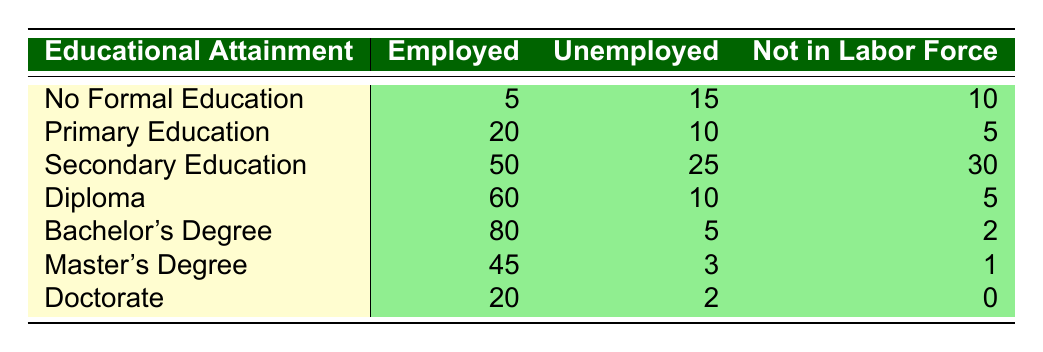What is the total number of unemployed Qatari citizens with a Bachelor's Degree? In the table, we find that the number of unemployed individuals with a Bachelor's Degree is listed as 5. Thus, the total number of unemployed Qatari citizens with this level of education is simply the number stated for that category.
Answer: 5 How many Qatari citizens are employed with only Primary Education? According to the table, under the category of Primary Education, the number of employed Qatari citizens is noted as 20. Therefore, this is a straightforward retrieval of the value from the table.
Answer: 20 What is the total number of Qatari citizens with no formal education? We need to sum the numbers of Employed, Unemployed, and Not in Labor Force for those with No Formal Education. It is calculated as 5 (Employed) + 15 (Unemployed) + 10 (Not in Labor Force) = 30. Hence, the total number of Qatari citizens with no formal education is 30.
Answer: 30 Is it true that more Qatari citizens with a Master's Degree are employed compared to those with a Doctorate? From the table, for Master's Degree we see 45 employed, while for Doctorate there are 20 employed. Since 45 is greater than 20, the statement is true.
Answer: Yes What is the average number of Qatari citizens employed across all educational attainment levels listed in the table? We sum all the Employed values: 5 + 20 + 50 + 60 + 80 + 45 + 20 = 280. There are 7 educational levels, so we calculate the average as 280 / 7 = 40.
Answer: 40 Which educational attainment level has the highest number of unemployed citizens? Looking at the table, we identify the highest value under the Unemployed column. The highest count is 25 under Secondary Education, which is greater than any other level listed.
Answer: Secondary Education How many Qatari citizens with a Diploma are either unemployed or not in the labor force? We add the Unemployed (10) and Not in Labor Force (5) numbers for those with a Diploma: 10 + 5 = 15. Therefore, a total of 15 citizens fall into the categories of either unemployed or not in the labor force.
Answer: 15 